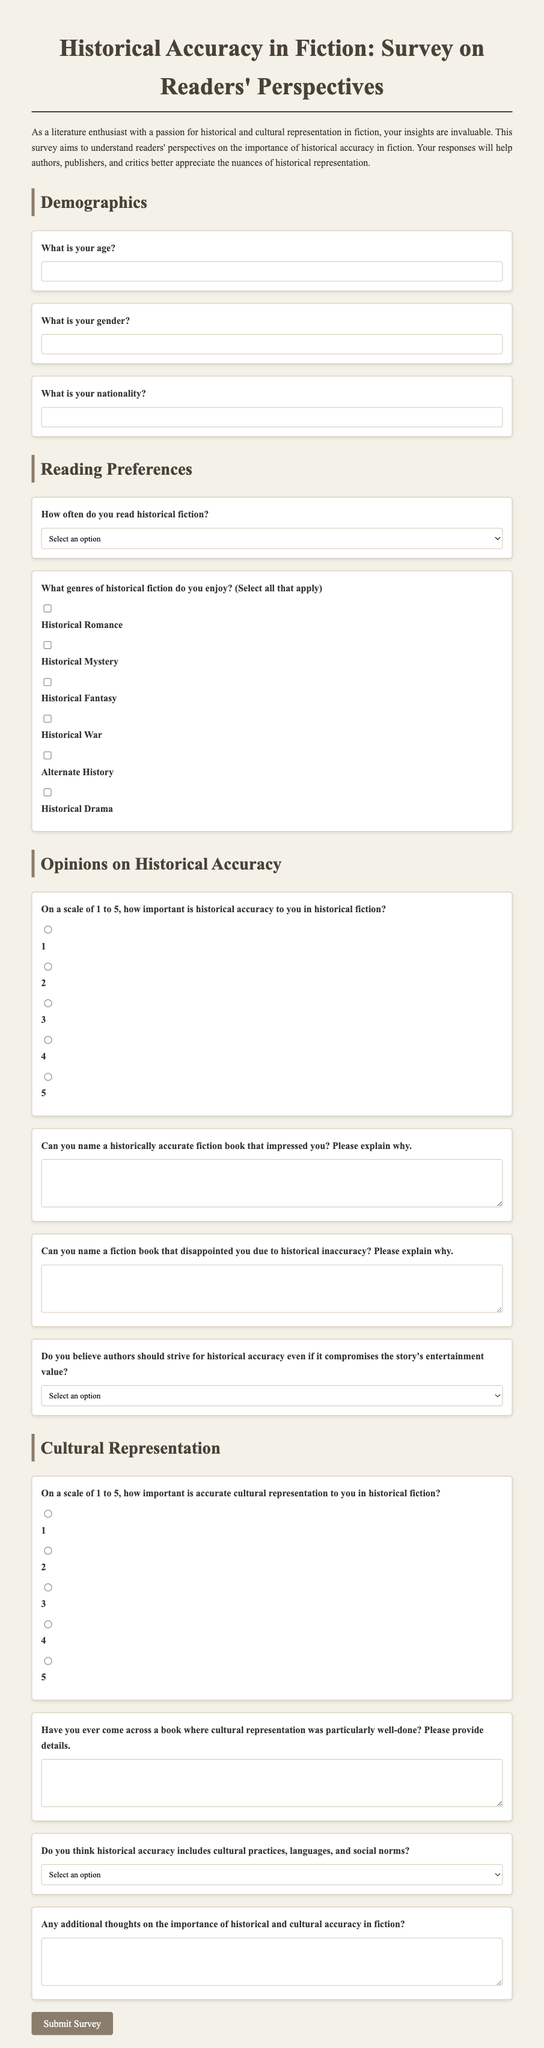What is the title of the survey? The title of the survey is clearly labeled at the top of the document.
Answer: Historical Accuracy in Fiction: Survey on Readers' Perspectives How many options are provided for reading frequency? The document lists the reading frequency options in a dropdown, which can be counted.
Answer: 4 What is the minimum age range specified in the survey? The survey asks for the respondent's age, indicating it should be a number.
Answer: No minimum specified What options are provided for the importance of historical accuracy? The survey includes a scale for respondents to express the importance of historical accuracy.
Answer: 1 to 5 What genre is NOT listed in the survey options? The survey includes a checkbox list for genre preferences in historical fiction; checking the list reveals certain genres are missing.
Answer: Fantasy (General) On a scale of 1 to 5, what is being assessed alongside historical accuracy? The survey assesses cultural representation and asks respondents to rate its importance.
Answer: Cultural representation How are additional thoughts collected in the survey? The document provides a dedicated area for respondents to express additional thoughts which can be identified as open-ended.
Answer: Text area What is required for the questions about historically accurate and inaccurate books? The survey explicitly mentions that respondents must provide a rationale for their selections regarding historically accurate or inaccurate books.
Answer: Explanation Should authors prioritize historical accuracy over entertainment value? The survey includes a question with selectable options reflecting the respondents' beliefs on this topic.
Answer: Selectable options 